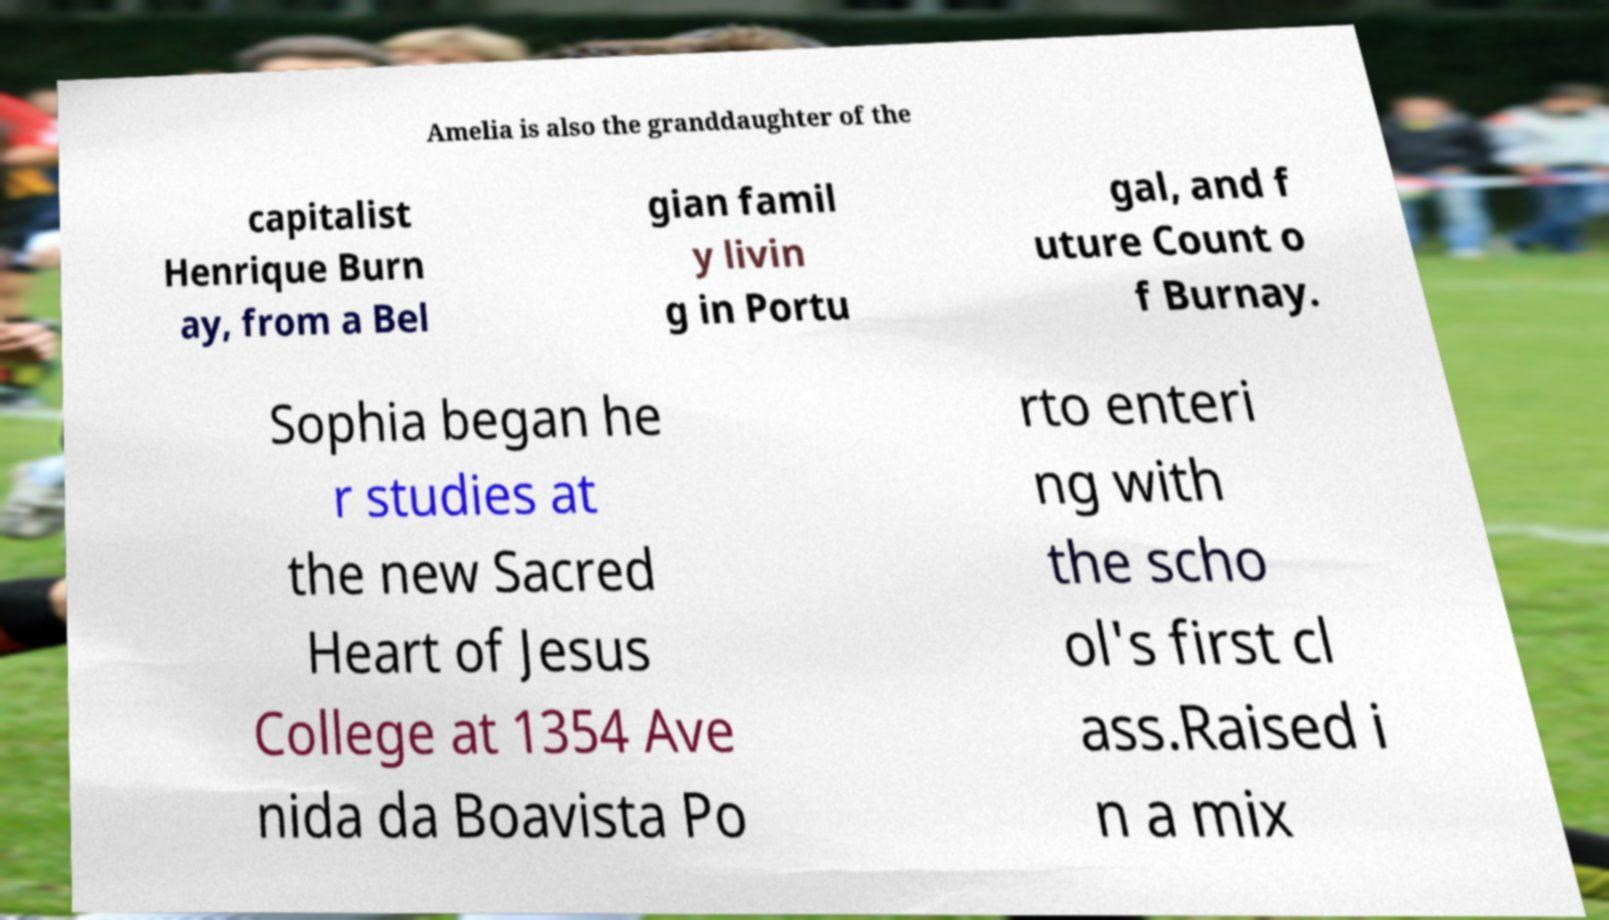Please read and relay the text visible in this image. What does it say? Amelia is also the granddaughter of the capitalist Henrique Burn ay, from a Bel gian famil y livin g in Portu gal, and f uture Count o f Burnay. Sophia began he r studies at the new Sacred Heart of Jesus College at 1354 Ave nida da Boavista Po rto enteri ng with the scho ol's first cl ass.Raised i n a mix 